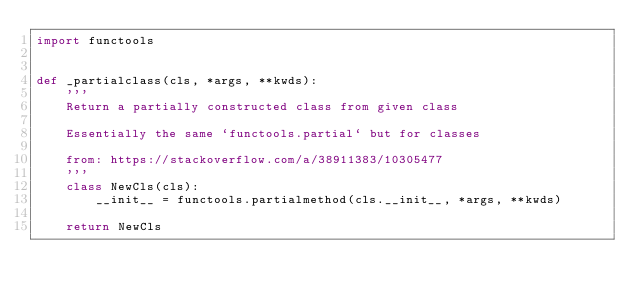<code> <loc_0><loc_0><loc_500><loc_500><_Python_>import functools


def _partialclass(cls, *args, **kwds):
    '''
    Return a partially constructed class from given class

    Essentially the same `functools.partial` but for classes
    
    from: https://stackoverflow.com/a/38911383/10305477
    '''
    class NewCls(cls):
        __init__ = functools.partialmethod(cls.__init__, *args, **kwds)

    return NewCls
</code> 